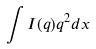<formula> <loc_0><loc_0><loc_500><loc_500>\int I ( q ) q ^ { 2 } d x</formula> 